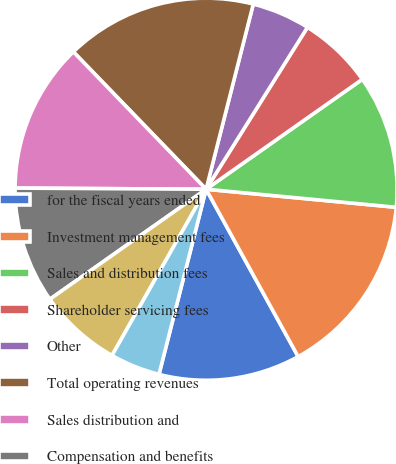<chart> <loc_0><loc_0><loc_500><loc_500><pie_chart><fcel>for the fiscal years ended<fcel>Investment management fees<fcel>Sales and distribution fees<fcel>Shareholder servicing fees<fcel>Other<fcel>Total operating revenues<fcel>Sales distribution and<fcel>Compensation and benefits<fcel>Information systems and<fcel>Occupancy<nl><fcel>11.97%<fcel>15.49%<fcel>11.27%<fcel>6.34%<fcel>4.93%<fcel>16.2%<fcel>12.68%<fcel>9.86%<fcel>7.04%<fcel>4.23%<nl></chart> 